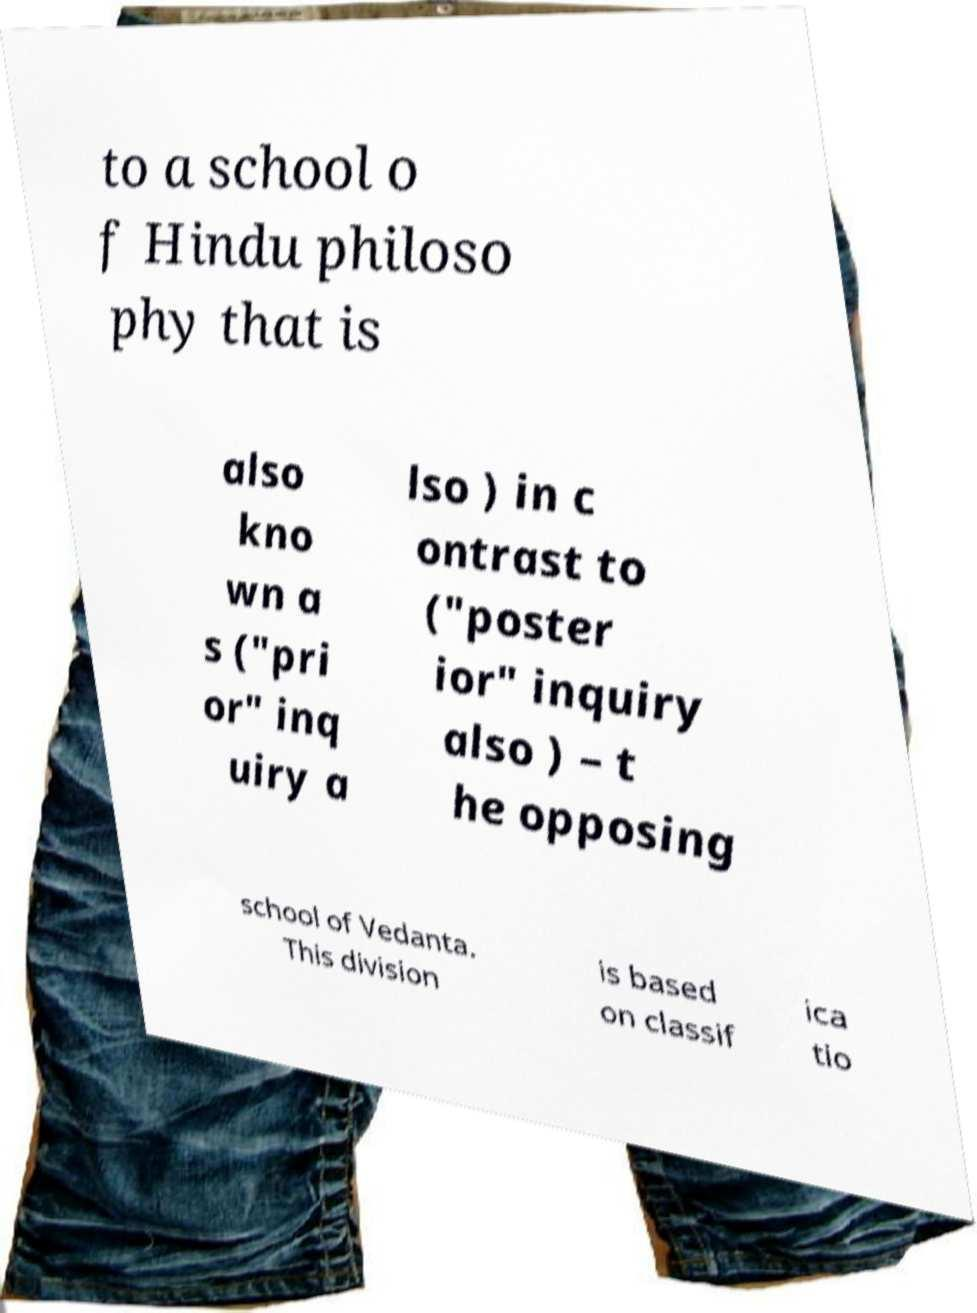Could you assist in decoding the text presented in this image and type it out clearly? to a school o f Hindu philoso phy that is also kno wn a s ("pri or" inq uiry a lso ) in c ontrast to ("poster ior" inquiry also ) – t he opposing school of Vedanta. This division is based on classif ica tio 